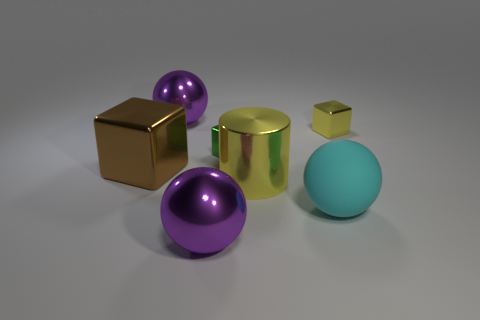Add 2 small green metal balls. How many objects exist? 9 Subtract all spheres. How many objects are left? 4 Subtract 0 green cylinders. How many objects are left? 7 Subtract all purple things. Subtract all tiny yellow metal cubes. How many objects are left? 4 Add 6 metal cylinders. How many metal cylinders are left? 7 Add 4 cyan cubes. How many cyan cubes exist? 4 